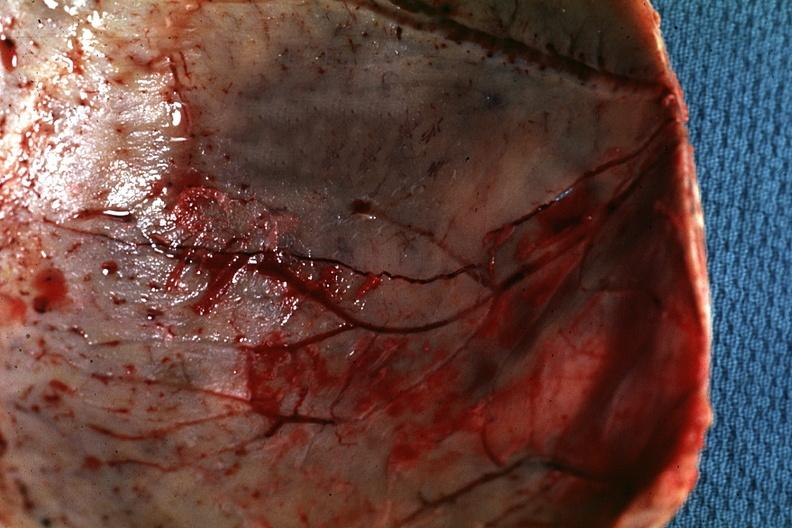s bone, calvarium present?
Answer the question using a single word or phrase. Yes 